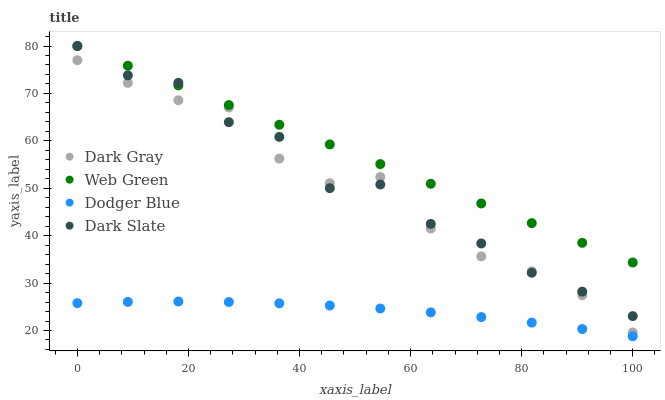Does Dodger Blue have the minimum area under the curve?
Answer yes or no. Yes. Does Web Green have the maximum area under the curve?
Answer yes or no. Yes. Does Dark Slate have the minimum area under the curve?
Answer yes or no. No. Does Dark Slate have the maximum area under the curve?
Answer yes or no. No. Is Web Green the smoothest?
Answer yes or no. Yes. Is Dark Slate the roughest?
Answer yes or no. Yes. Is Dodger Blue the smoothest?
Answer yes or no. No. Is Dodger Blue the roughest?
Answer yes or no. No. Does Dodger Blue have the lowest value?
Answer yes or no. Yes. Does Dark Slate have the lowest value?
Answer yes or no. No. Does Web Green have the highest value?
Answer yes or no. Yes. Does Dodger Blue have the highest value?
Answer yes or no. No. Is Dark Gray less than Web Green?
Answer yes or no. Yes. Is Dark Gray greater than Dodger Blue?
Answer yes or no. Yes. Does Dark Gray intersect Dark Slate?
Answer yes or no. Yes. Is Dark Gray less than Dark Slate?
Answer yes or no. No. Is Dark Gray greater than Dark Slate?
Answer yes or no. No. Does Dark Gray intersect Web Green?
Answer yes or no. No. 